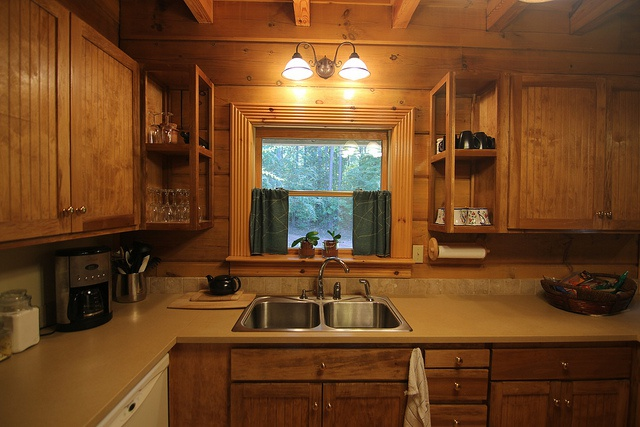Describe the objects in this image and their specific colors. I can see sink in maroon, black, and olive tones, bowl in maroon, black, and olive tones, potted plant in maroon, black, darkgreen, and gray tones, potted plant in maroon, black, gray, and olive tones, and wine glass in maroon, brown, and gray tones in this image. 